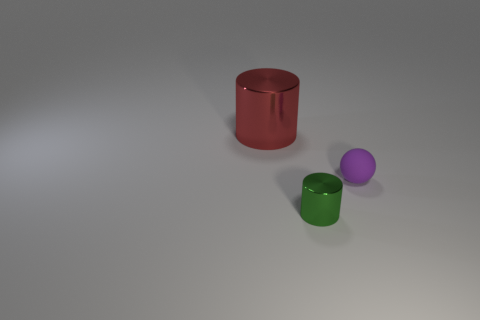Is there anything else that has the same material as the tiny purple thing?
Give a very brief answer. No. What is the object that is both on the left side of the small rubber ball and behind the tiny cylinder made of?
Offer a very short reply. Metal. What number of shiny objects are in front of the small sphere?
Your answer should be very brief. 1. Is the shape of the big object the same as the small object in front of the tiny matte ball?
Make the answer very short. Yes. Are there any green shiny things that have the same shape as the red metal object?
Your response must be concise. Yes. There is a metallic object in front of the metallic object that is behind the small purple rubber sphere; what is its shape?
Keep it short and to the point. Cylinder. There is a tiny thing that is to the right of the tiny green metal cylinder; what is its shape?
Give a very brief answer. Sphere. What number of things are in front of the large metallic thing and left of the small purple rubber object?
Offer a very short reply. 1. The green object that is the same material as the large red cylinder is what size?
Give a very brief answer. Small. The red shiny cylinder has what size?
Provide a short and direct response. Large. 